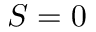<formula> <loc_0><loc_0><loc_500><loc_500>S = 0</formula> 